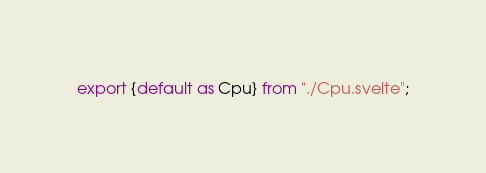Convert code to text. <code><loc_0><loc_0><loc_500><loc_500><_JavaScript_>export {default as Cpu} from "./Cpu.svelte";</code> 